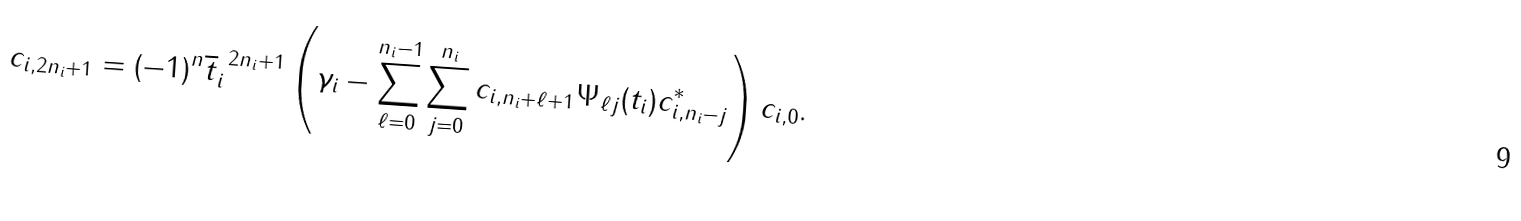<formula> <loc_0><loc_0><loc_500><loc_500>c _ { i , 2 n _ { i } + 1 } = ( - 1 ) ^ { n } \overline { t } _ { i } ^ { \ 2 n _ { i } + 1 } \left ( \gamma _ { i } - \sum _ { \ell = 0 } ^ { n _ { i } - 1 } \sum _ { j = 0 } ^ { n _ { i } } c _ { i , n _ { i } + \ell + 1 } \Psi _ { \ell j } ( t _ { i } ) { c } _ { i , n _ { i } - j } ^ { * } \right ) c _ { i , 0 } .</formula> 